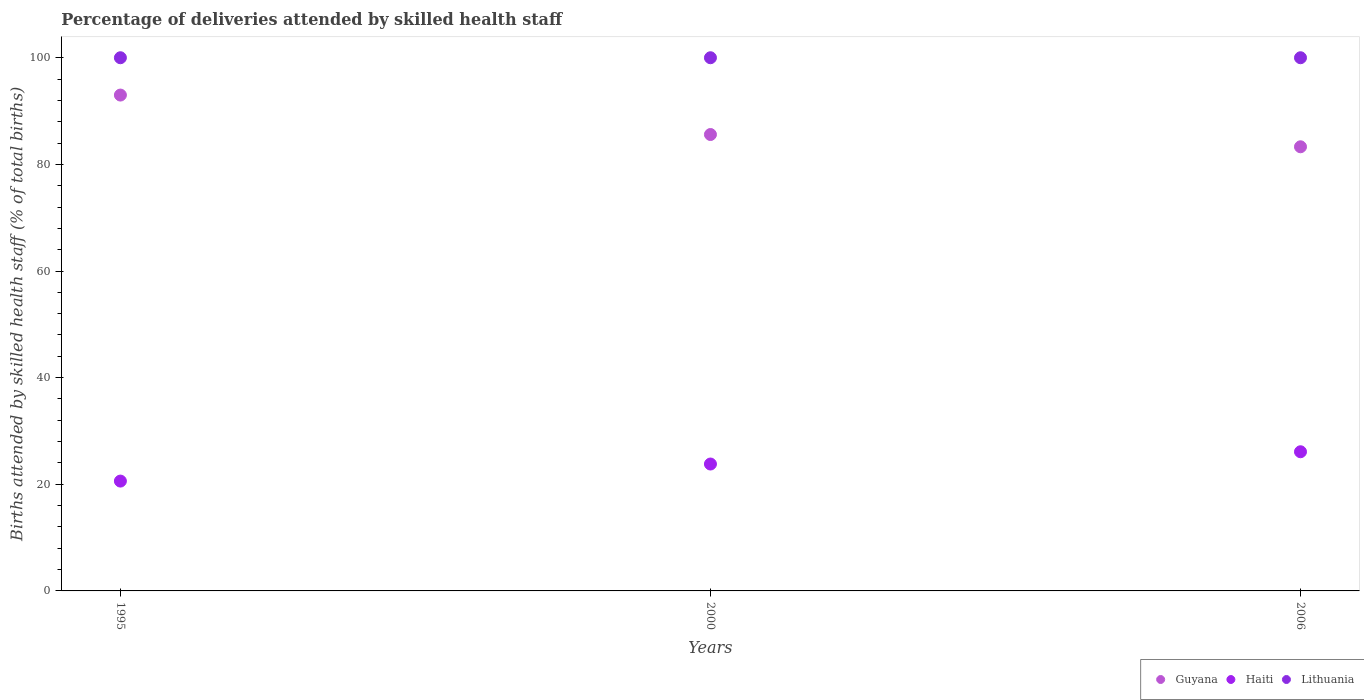How many different coloured dotlines are there?
Offer a very short reply. 3. What is the percentage of births attended by skilled health staff in Lithuania in 1995?
Ensure brevity in your answer.  100. Across all years, what is the maximum percentage of births attended by skilled health staff in Lithuania?
Make the answer very short. 100. Across all years, what is the minimum percentage of births attended by skilled health staff in Lithuania?
Provide a short and direct response. 100. What is the total percentage of births attended by skilled health staff in Lithuania in the graph?
Keep it short and to the point. 300. What is the difference between the percentage of births attended by skilled health staff in Haiti in 1995 and the percentage of births attended by skilled health staff in Guyana in 2000?
Offer a very short reply. -65. What is the average percentage of births attended by skilled health staff in Guyana per year?
Provide a short and direct response. 87.3. In the year 2000, what is the difference between the percentage of births attended by skilled health staff in Lithuania and percentage of births attended by skilled health staff in Haiti?
Provide a short and direct response. 76.2. In how many years, is the percentage of births attended by skilled health staff in Haiti greater than 24 %?
Give a very brief answer. 1. What is the ratio of the percentage of births attended by skilled health staff in Haiti in 2000 to that in 2006?
Provide a short and direct response. 0.91. Is the percentage of births attended by skilled health staff in Haiti in 1995 less than that in 2000?
Ensure brevity in your answer.  Yes. Is it the case that in every year, the sum of the percentage of births attended by skilled health staff in Lithuania and percentage of births attended by skilled health staff in Haiti  is greater than the percentage of births attended by skilled health staff in Guyana?
Offer a very short reply. Yes. Does the percentage of births attended by skilled health staff in Haiti monotonically increase over the years?
Your response must be concise. Yes. Is the percentage of births attended by skilled health staff in Guyana strictly less than the percentage of births attended by skilled health staff in Lithuania over the years?
Your answer should be compact. Yes. How many dotlines are there?
Give a very brief answer. 3. How many years are there in the graph?
Your response must be concise. 3. What is the difference between two consecutive major ticks on the Y-axis?
Offer a terse response. 20. Are the values on the major ticks of Y-axis written in scientific E-notation?
Offer a very short reply. No. How many legend labels are there?
Ensure brevity in your answer.  3. How are the legend labels stacked?
Your answer should be compact. Horizontal. What is the title of the graph?
Make the answer very short. Percentage of deliveries attended by skilled health staff. What is the label or title of the Y-axis?
Ensure brevity in your answer.  Births attended by skilled health staff (% of total births). What is the Births attended by skilled health staff (% of total births) in Guyana in 1995?
Offer a very short reply. 93. What is the Births attended by skilled health staff (% of total births) in Haiti in 1995?
Give a very brief answer. 20.6. What is the Births attended by skilled health staff (% of total births) in Guyana in 2000?
Your answer should be very brief. 85.6. What is the Births attended by skilled health staff (% of total births) of Haiti in 2000?
Your response must be concise. 23.8. What is the Births attended by skilled health staff (% of total births) of Lithuania in 2000?
Provide a short and direct response. 100. What is the Births attended by skilled health staff (% of total births) in Guyana in 2006?
Your answer should be compact. 83.3. What is the Births attended by skilled health staff (% of total births) of Haiti in 2006?
Provide a succinct answer. 26.1. Across all years, what is the maximum Births attended by skilled health staff (% of total births) in Guyana?
Offer a very short reply. 93. Across all years, what is the maximum Births attended by skilled health staff (% of total births) of Haiti?
Keep it short and to the point. 26.1. Across all years, what is the minimum Births attended by skilled health staff (% of total births) in Guyana?
Offer a very short reply. 83.3. Across all years, what is the minimum Births attended by skilled health staff (% of total births) in Haiti?
Offer a terse response. 20.6. Across all years, what is the minimum Births attended by skilled health staff (% of total births) of Lithuania?
Offer a terse response. 100. What is the total Births attended by skilled health staff (% of total births) of Guyana in the graph?
Your response must be concise. 261.9. What is the total Births attended by skilled health staff (% of total births) of Haiti in the graph?
Make the answer very short. 70.5. What is the total Births attended by skilled health staff (% of total births) in Lithuania in the graph?
Offer a very short reply. 300. What is the difference between the Births attended by skilled health staff (% of total births) in Guyana in 1995 and that in 2000?
Your response must be concise. 7.4. What is the difference between the Births attended by skilled health staff (% of total births) of Lithuania in 1995 and that in 2000?
Provide a succinct answer. 0. What is the difference between the Births attended by skilled health staff (% of total births) in Lithuania in 2000 and that in 2006?
Give a very brief answer. 0. What is the difference between the Births attended by skilled health staff (% of total births) in Guyana in 1995 and the Births attended by skilled health staff (% of total births) in Haiti in 2000?
Keep it short and to the point. 69.2. What is the difference between the Births attended by skilled health staff (% of total births) of Guyana in 1995 and the Births attended by skilled health staff (% of total births) of Lithuania in 2000?
Provide a succinct answer. -7. What is the difference between the Births attended by skilled health staff (% of total births) of Haiti in 1995 and the Births attended by skilled health staff (% of total births) of Lithuania in 2000?
Offer a terse response. -79.4. What is the difference between the Births attended by skilled health staff (% of total births) in Guyana in 1995 and the Births attended by skilled health staff (% of total births) in Haiti in 2006?
Offer a terse response. 66.9. What is the difference between the Births attended by skilled health staff (% of total births) of Haiti in 1995 and the Births attended by skilled health staff (% of total births) of Lithuania in 2006?
Offer a terse response. -79.4. What is the difference between the Births attended by skilled health staff (% of total births) of Guyana in 2000 and the Births attended by skilled health staff (% of total births) of Haiti in 2006?
Offer a terse response. 59.5. What is the difference between the Births attended by skilled health staff (% of total births) in Guyana in 2000 and the Births attended by skilled health staff (% of total births) in Lithuania in 2006?
Offer a terse response. -14.4. What is the difference between the Births attended by skilled health staff (% of total births) of Haiti in 2000 and the Births attended by skilled health staff (% of total births) of Lithuania in 2006?
Make the answer very short. -76.2. What is the average Births attended by skilled health staff (% of total births) of Guyana per year?
Provide a short and direct response. 87.3. What is the average Births attended by skilled health staff (% of total births) in Haiti per year?
Ensure brevity in your answer.  23.5. In the year 1995, what is the difference between the Births attended by skilled health staff (% of total births) in Guyana and Births attended by skilled health staff (% of total births) in Haiti?
Offer a very short reply. 72.4. In the year 1995, what is the difference between the Births attended by skilled health staff (% of total births) of Haiti and Births attended by skilled health staff (% of total births) of Lithuania?
Give a very brief answer. -79.4. In the year 2000, what is the difference between the Births attended by skilled health staff (% of total births) in Guyana and Births attended by skilled health staff (% of total births) in Haiti?
Offer a terse response. 61.8. In the year 2000, what is the difference between the Births attended by skilled health staff (% of total births) in Guyana and Births attended by skilled health staff (% of total births) in Lithuania?
Your response must be concise. -14.4. In the year 2000, what is the difference between the Births attended by skilled health staff (% of total births) in Haiti and Births attended by skilled health staff (% of total births) in Lithuania?
Your response must be concise. -76.2. In the year 2006, what is the difference between the Births attended by skilled health staff (% of total births) of Guyana and Births attended by skilled health staff (% of total births) of Haiti?
Ensure brevity in your answer.  57.2. In the year 2006, what is the difference between the Births attended by skilled health staff (% of total births) of Guyana and Births attended by skilled health staff (% of total births) of Lithuania?
Provide a short and direct response. -16.7. In the year 2006, what is the difference between the Births attended by skilled health staff (% of total births) of Haiti and Births attended by skilled health staff (% of total births) of Lithuania?
Make the answer very short. -73.9. What is the ratio of the Births attended by skilled health staff (% of total births) of Guyana in 1995 to that in 2000?
Keep it short and to the point. 1.09. What is the ratio of the Births attended by skilled health staff (% of total births) of Haiti in 1995 to that in 2000?
Keep it short and to the point. 0.87. What is the ratio of the Births attended by skilled health staff (% of total births) in Lithuania in 1995 to that in 2000?
Your answer should be very brief. 1. What is the ratio of the Births attended by skilled health staff (% of total births) of Guyana in 1995 to that in 2006?
Offer a very short reply. 1.12. What is the ratio of the Births attended by skilled health staff (% of total births) of Haiti in 1995 to that in 2006?
Give a very brief answer. 0.79. What is the ratio of the Births attended by skilled health staff (% of total births) of Guyana in 2000 to that in 2006?
Make the answer very short. 1.03. What is the ratio of the Births attended by skilled health staff (% of total births) in Haiti in 2000 to that in 2006?
Give a very brief answer. 0.91. What is the difference between the highest and the second highest Births attended by skilled health staff (% of total births) of Haiti?
Ensure brevity in your answer.  2.3. What is the difference between the highest and the second highest Births attended by skilled health staff (% of total births) of Lithuania?
Your answer should be compact. 0. What is the difference between the highest and the lowest Births attended by skilled health staff (% of total births) of Guyana?
Keep it short and to the point. 9.7. What is the difference between the highest and the lowest Births attended by skilled health staff (% of total births) of Lithuania?
Offer a very short reply. 0. 